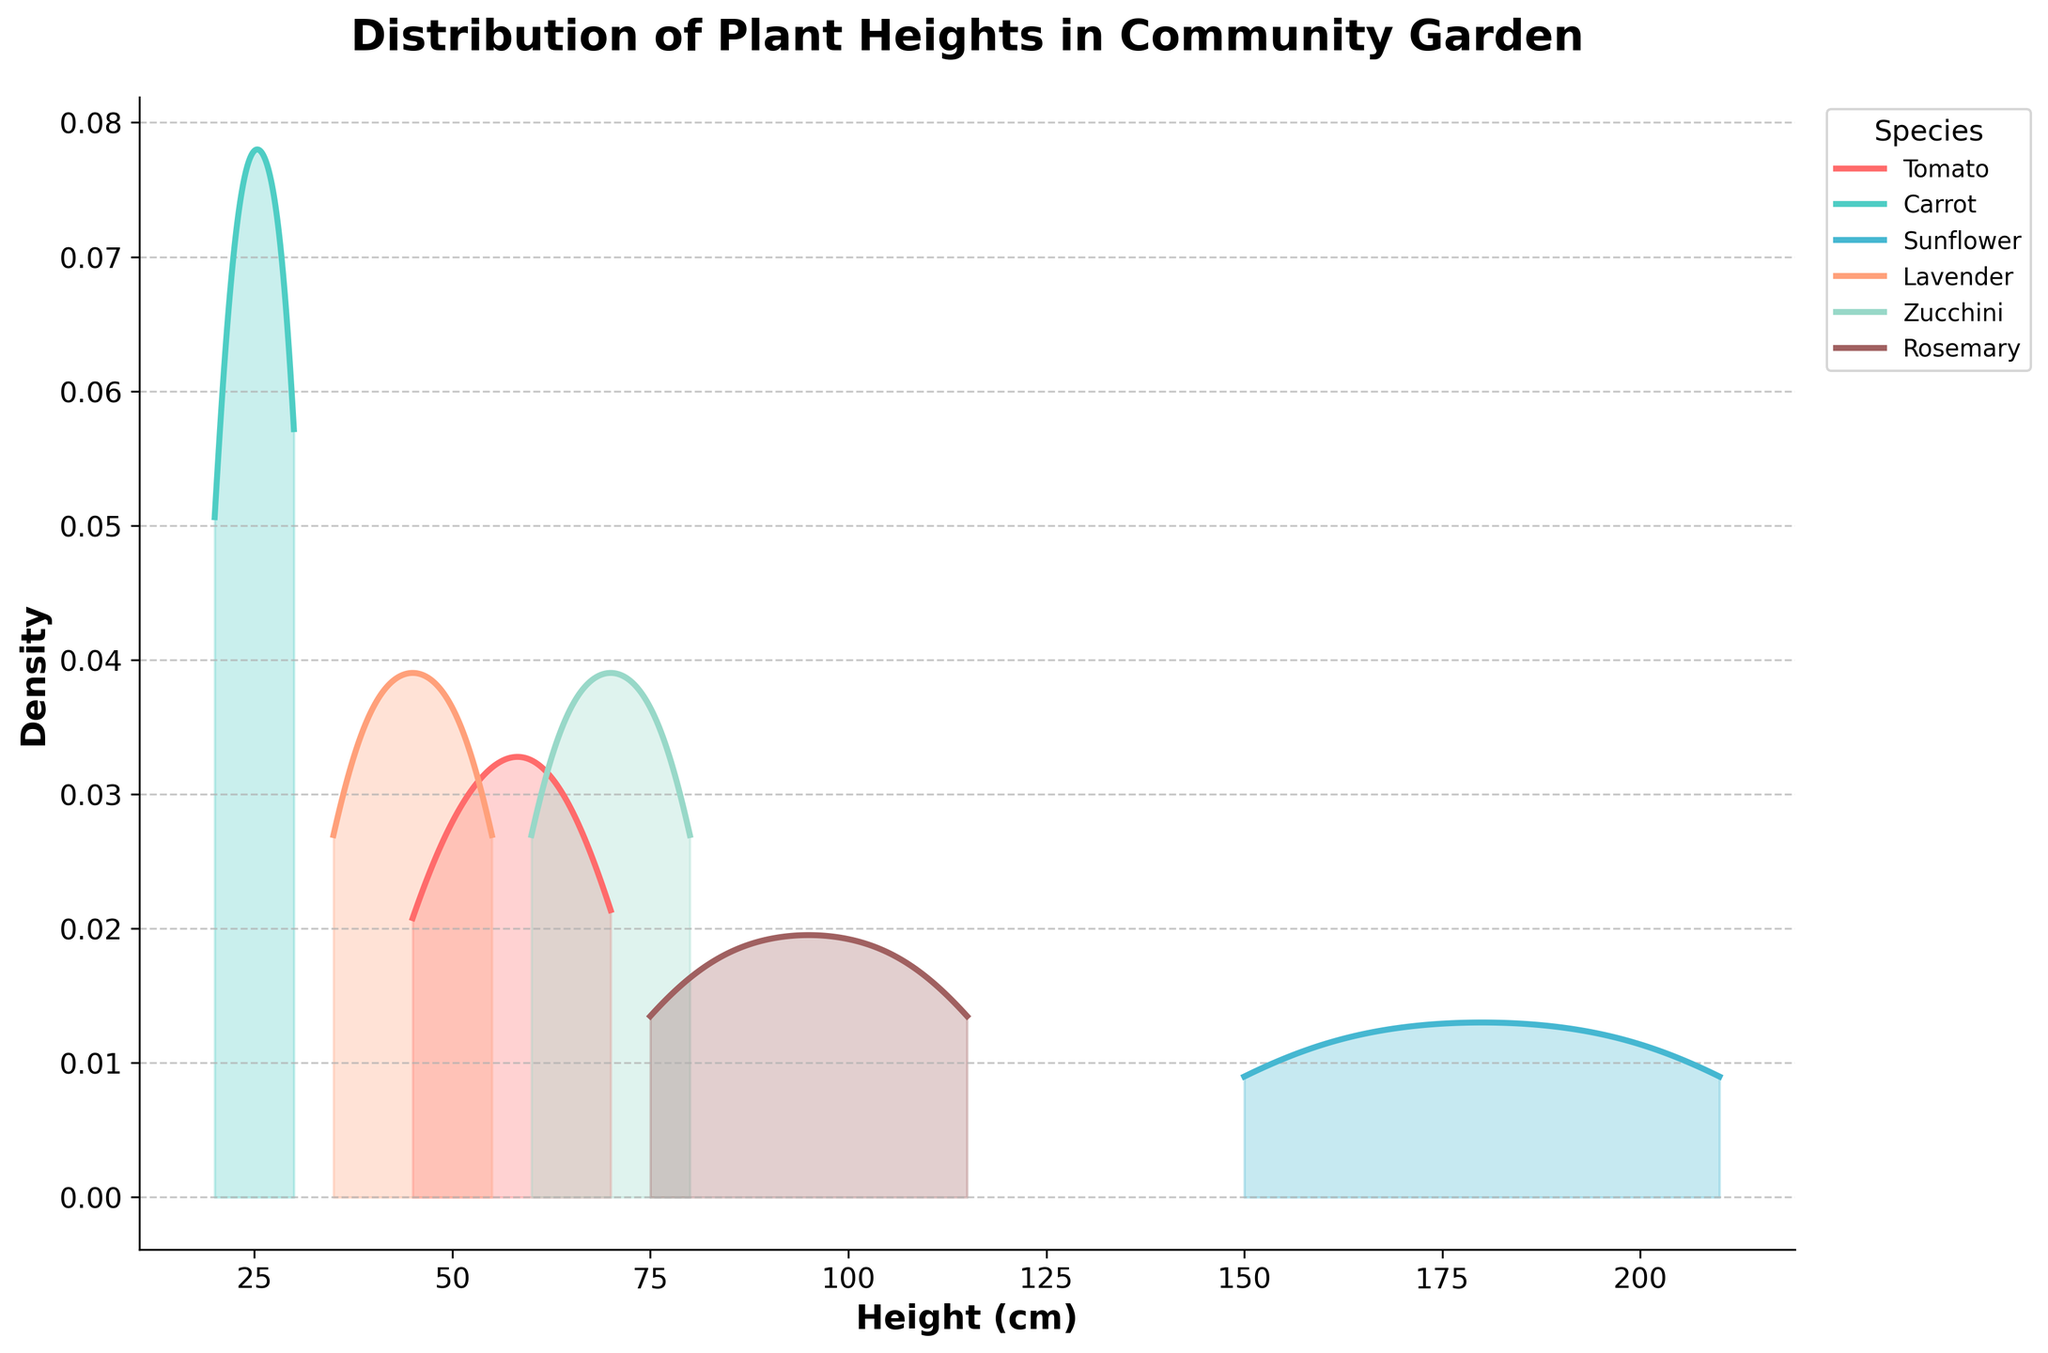What species has the tallest distribution of plant heights? By examining the density plot, we see that the Sunflower species has the tallest peak in plant heights, ranging from 150 cm to 210 cm, which is the largest height range among all species.
Answer: Sunflower Which species has the shortest height distribution? The Carrot species has the shortest height distribution. This is evident as its density plot is concentrated within the range of 20 cm to 30 cm, which is the smallest height range compared to the other species.
Answer: Carrot What's the height range for Zucchini plants? Observing the density plot for Zucchini, we note that its range spans from around 60 cm to 80 cm, as reflected by the starting and end points of its density curve.
Answer: 60-80 cm How do the height distributions of Lavender and Rosemary compare? By looking at the density plots for Lavender and Rosemary, we can see that Rosemary plants are generally taller, ranging from 75 cm to 115 cm, while Lavender plants range from about 35 cm to 55 cm. Thus, Rosemary has a higher overall height distribution.
Answer: Rosemary is taller Which species has the highest peak density in the plot? Examining the density curves, we can identify that the highest peak density is for the Carrot species, indicating that there is a higher concentration of heights around its median compared to other species.
Answer: Carrot Between Tomato and Zucchini, which species has a wider range of heights? The density plot shows that Tomato plants range from approximately 45 cm to 70 cm, while Zucchini plants range from 60 cm to 80 cm. Thus, the range for Zucchini is slightly wider.
Answer: Zucchini Are there any species whose height distributions overlap significantly? The density plots of Lavender (35-55 cm) and Tomato (45-70 cm) show some overlap in their height distributions. This is particularly evident in the range of around 45 to 55 cm.
Answer: Lavender and Tomato What is the peak height of the Sunflower species' distribution? Observing the Sunflower species' density plot, the peak height, where the density curve is highest, appears around 180 cm.
Answer: 180 cm Which species are more densely populated at shorter heights? The density plots reveal that both Carrot (20-30 cm) and Lavender (35-55 cm) are more densely populated at shorter heights as compared to other species.
Answer: Carrot and Lavender Does any species have a bimodal distribution? Observing the density plots, none of the species exhibit a bimodal distribution, as all density plots have a single peak, indicating a unimodal distribution for each species.
Answer: No 